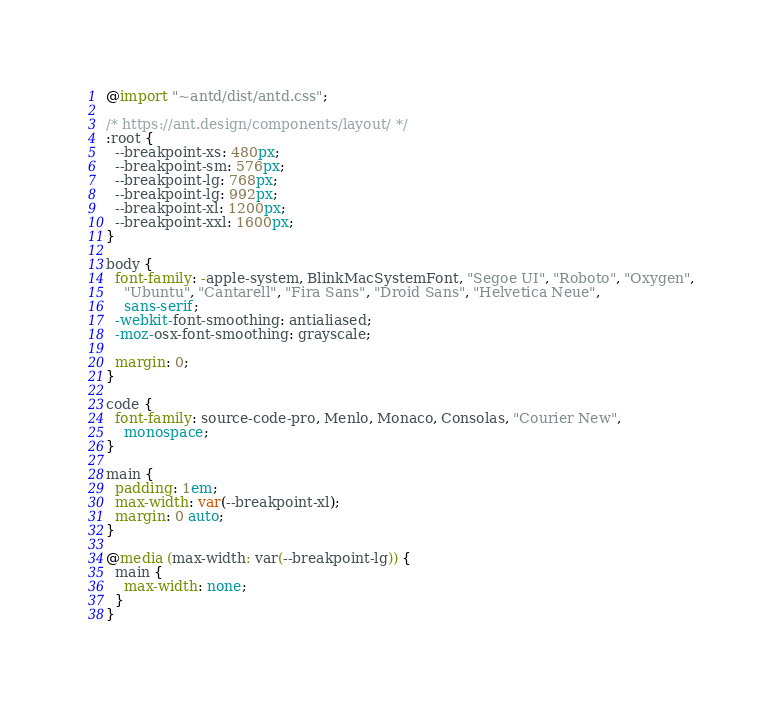<code> <loc_0><loc_0><loc_500><loc_500><_CSS_>@import "~antd/dist/antd.css";

/* https://ant.design/components/layout/ */
:root {
  --breakpoint-xs: 480px;
  --breakpoint-sm: 576px;
  --breakpoint-lg: 768px;
  --breakpoint-lg: 992px;
  --breakpoint-xl: 1200px;
  --breakpoint-xxl: 1600px;
}

body {
  font-family: -apple-system, BlinkMacSystemFont, "Segoe UI", "Roboto", "Oxygen",
    "Ubuntu", "Cantarell", "Fira Sans", "Droid Sans", "Helvetica Neue",
    sans-serif;
  -webkit-font-smoothing: antialiased;
  -moz-osx-font-smoothing: grayscale;

  margin: 0;
}

code {
  font-family: source-code-pro, Menlo, Monaco, Consolas, "Courier New",
    monospace;
}

main {
  padding: 1em;
  max-width: var(--breakpoint-xl);
  margin: 0 auto;
}

@media (max-width: var(--breakpoint-lg)) {
  main {
    max-width: none;
  }
}
</code> 